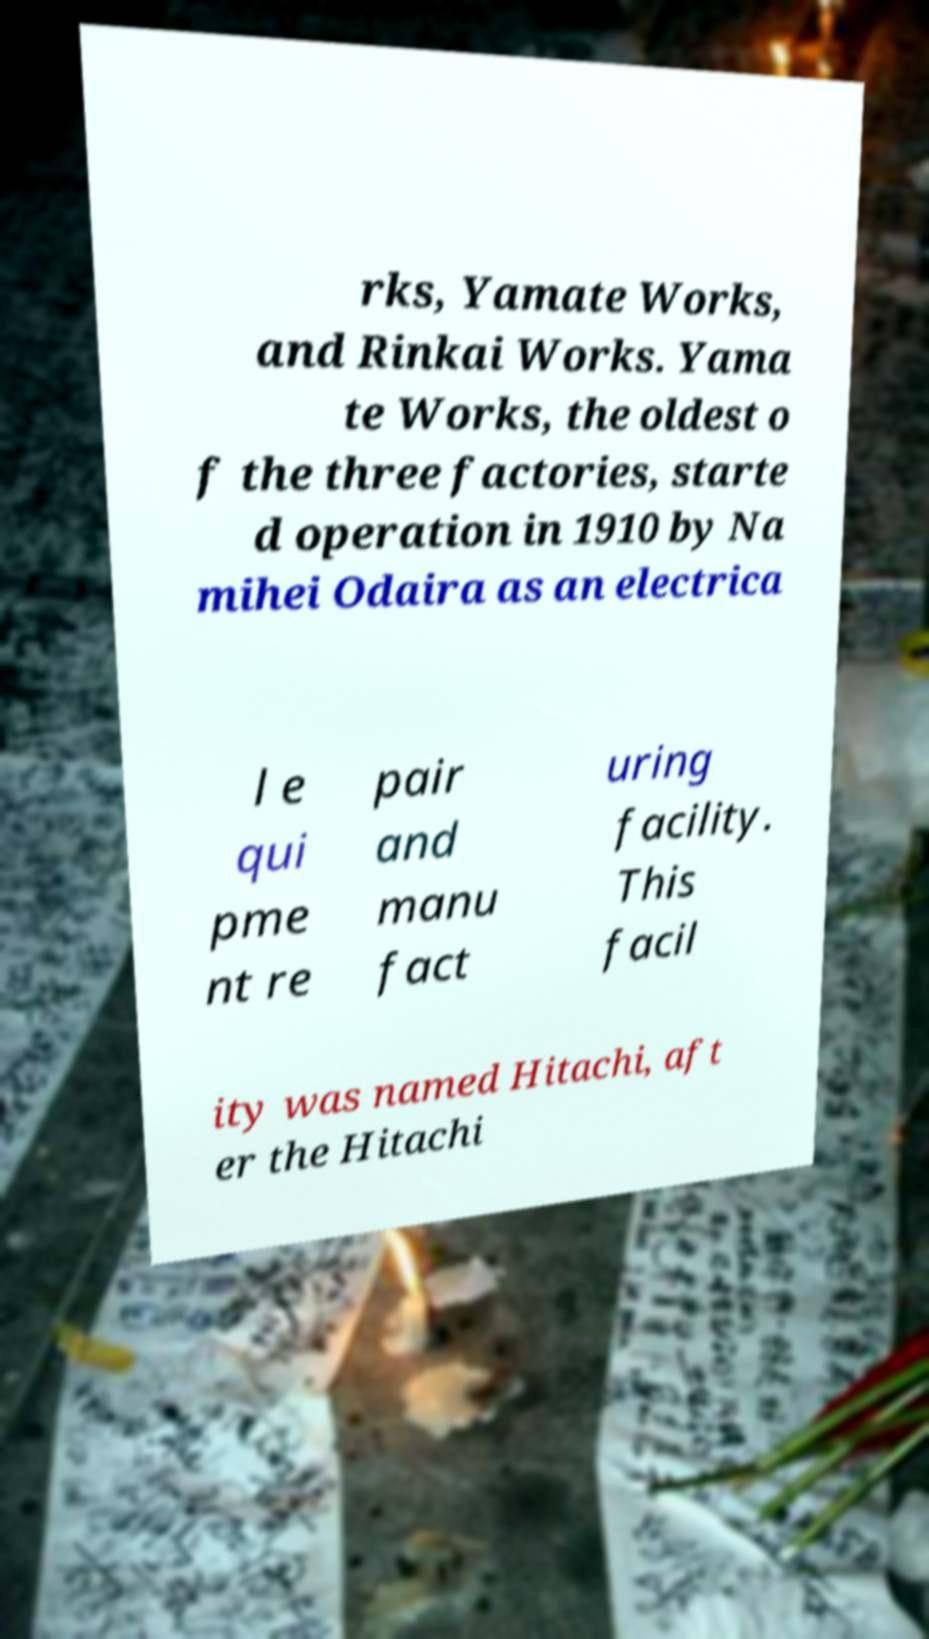Could you extract and type out the text from this image? rks, Yamate Works, and Rinkai Works. Yama te Works, the oldest o f the three factories, starte d operation in 1910 by Na mihei Odaira as an electrica l e qui pme nt re pair and manu fact uring facility. This facil ity was named Hitachi, aft er the Hitachi 